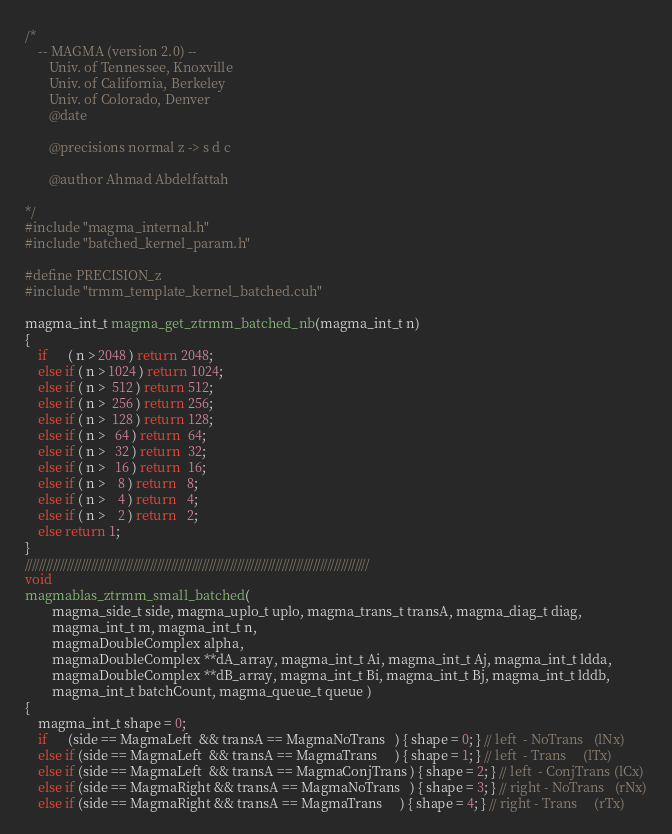Convert code to text. <code><loc_0><loc_0><loc_500><loc_500><_Cuda_>/*
    -- MAGMA (version 2.0) --
       Univ. of Tennessee, Knoxville
       Univ. of California, Berkeley
       Univ. of Colorado, Denver
       @date

       @precisions normal z -> s d c

       @author Ahmad Abdelfattah
       
*/
#include "magma_internal.h"
#include "batched_kernel_param.h"

#define PRECISION_z
#include "trmm_template_kernel_batched.cuh"

magma_int_t magma_get_ztrmm_batched_nb(magma_int_t n)
{
    if      ( n > 2048 ) return 2048;
    else if ( n > 1024 ) return 1024;
    else if ( n >  512 ) return 512;
    else if ( n >  256 ) return 256;
    else if ( n >  128 ) return 128;
    else if ( n >   64 ) return  64;
    else if ( n >   32 ) return  32;
    else if ( n >   16 ) return  16;
    else if ( n >    8 ) return   8;
    else if ( n >    4 ) return   4;
    else if ( n >    2 ) return   2;
    else return 1;
}
///////////////////////////////////////////////////////////////////////////////////////////////////
void
magmablas_ztrmm_small_batched(
        magma_side_t side, magma_uplo_t uplo, magma_trans_t transA, magma_diag_t diag, 
        magma_int_t m, magma_int_t n, 
        magmaDoubleComplex alpha, 
        magmaDoubleComplex **dA_array, magma_int_t Ai, magma_int_t Aj, magma_int_t ldda,
        magmaDoubleComplex **dB_array, magma_int_t Bi, magma_int_t Bj, magma_int_t lddb, 
        magma_int_t batchCount, magma_queue_t queue )
{
    magma_int_t shape = 0;
    if      (side == MagmaLeft  && transA == MagmaNoTrans   ) { shape = 0; } // left  - NoTrans   (lNx)
    else if (side == MagmaLeft  && transA == MagmaTrans     ) { shape = 1; } // left  - Trans     (lTx)
    else if (side == MagmaLeft  && transA == MagmaConjTrans ) { shape = 2; } // left  - ConjTrans (lCx)
    else if (side == MagmaRight && transA == MagmaNoTrans   ) { shape = 3; } // right - NoTrans   (rNx)
    else if (side == MagmaRight && transA == MagmaTrans     ) { shape = 4; } // right - Trans     (rTx)</code> 